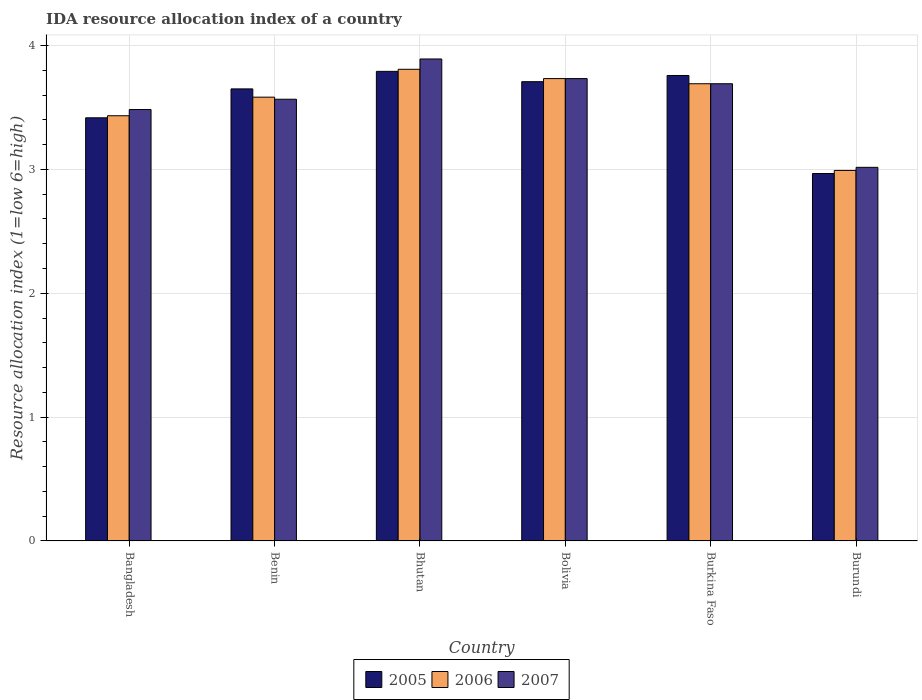How many groups of bars are there?
Offer a very short reply. 6. Are the number of bars on each tick of the X-axis equal?
Your response must be concise. Yes. What is the IDA resource allocation index in 2007 in Burkina Faso?
Your response must be concise. 3.69. Across all countries, what is the maximum IDA resource allocation index in 2005?
Make the answer very short. 3.79. Across all countries, what is the minimum IDA resource allocation index in 2006?
Offer a terse response. 2.99. In which country was the IDA resource allocation index in 2006 maximum?
Your response must be concise. Bhutan. In which country was the IDA resource allocation index in 2005 minimum?
Provide a succinct answer. Burundi. What is the total IDA resource allocation index in 2006 in the graph?
Provide a succinct answer. 21.24. What is the difference between the IDA resource allocation index in 2005 in Bangladesh and that in Bhutan?
Make the answer very short. -0.38. What is the difference between the IDA resource allocation index in 2005 in Bhutan and the IDA resource allocation index in 2006 in Burkina Faso?
Provide a short and direct response. 0.1. What is the average IDA resource allocation index in 2006 per country?
Offer a very short reply. 3.54. What is the difference between the IDA resource allocation index of/in 2005 and IDA resource allocation index of/in 2006 in Bolivia?
Your response must be concise. -0.02. In how many countries, is the IDA resource allocation index in 2005 greater than 2.2?
Give a very brief answer. 6. What is the ratio of the IDA resource allocation index in 2006 in Bolivia to that in Burundi?
Make the answer very short. 1.25. Is the difference between the IDA resource allocation index in 2005 in Benin and Bolivia greater than the difference between the IDA resource allocation index in 2006 in Benin and Bolivia?
Your answer should be very brief. Yes. What is the difference between the highest and the second highest IDA resource allocation index in 2006?
Offer a terse response. 0.04. What is the difference between the highest and the lowest IDA resource allocation index in 2005?
Offer a terse response. 0.83. In how many countries, is the IDA resource allocation index in 2005 greater than the average IDA resource allocation index in 2005 taken over all countries?
Your response must be concise. 4. What does the 1st bar from the left in Burundi represents?
Offer a very short reply. 2005. Is it the case that in every country, the sum of the IDA resource allocation index in 2006 and IDA resource allocation index in 2005 is greater than the IDA resource allocation index in 2007?
Make the answer very short. Yes. How many countries are there in the graph?
Give a very brief answer. 6. What is the difference between two consecutive major ticks on the Y-axis?
Your response must be concise. 1. Are the values on the major ticks of Y-axis written in scientific E-notation?
Provide a short and direct response. No. Does the graph contain any zero values?
Offer a very short reply. No. What is the title of the graph?
Keep it short and to the point. IDA resource allocation index of a country. Does "1995" appear as one of the legend labels in the graph?
Give a very brief answer. No. What is the label or title of the Y-axis?
Keep it short and to the point. Resource allocation index (1=low 6=high). What is the Resource allocation index (1=low 6=high) of 2005 in Bangladesh?
Make the answer very short. 3.42. What is the Resource allocation index (1=low 6=high) of 2006 in Bangladesh?
Offer a terse response. 3.43. What is the Resource allocation index (1=low 6=high) of 2007 in Bangladesh?
Your response must be concise. 3.48. What is the Resource allocation index (1=low 6=high) in 2005 in Benin?
Provide a succinct answer. 3.65. What is the Resource allocation index (1=low 6=high) of 2006 in Benin?
Your answer should be compact. 3.58. What is the Resource allocation index (1=low 6=high) in 2007 in Benin?
Offer a terse response. 3.57. What is the Resource allocation index (1=low 6=high) in 2005 in Bhutan?
Your answer should be compact. 3.79. What is the Resource allocation index (1=low 6=high) of 2006 in Bhutan?
Offer a very short reply. 3.81. What is the Resource allocation index (1=low 6=high) of 2007 in Bhutan?
Provide a short and direct response. 3.89. What is the Resource allocation index (1=low 6=high) of 2005 in Bolivia?
Your answer should be very brief. 3.71. What is the Resource allocation index (1=low 6=high) in 2006 in Bolivia?
Ensure brevity in your answer.  3.73. What is the Resource allocation index (1=low 6=high) in 2007 in Bolivia?
Give a very brief answer. 3.73. What is the Resource allocation index (1=low 6=high) in 2005 in Burkina Faso?
Your answer should be compact. 3.76. What is the Resource allocation index (1=low 6=high) of 2006 in Burkina Faso?
Make the answer very short. 3.69. What is the Resource allocation index (1=low 6=high) of 2007 in Burkina Faso?
Offer a very short reply. 3.69. What is the Resource allocation index (1=low 6=high) of 2005 in Burundi?
Your answer should be very brief. 2.97. What is the Resource allocation index (1=low 6=high) in 2006 in Burundi?
Your answer should be very brief. 2.99. What is the Resource allocation index (1=low 6=high) of 2007 in Burundi?
Your answer should be very brief. 3.02. Across all countries, what is the maximum Resource allocation index (1=low 6=high) of 2005?
Keep it short and to the point. 3.79. Across all countries, what is the maximum Resource allocation index (1=low 6=high) of 2006?
Your answer should be compact. 3.81. Across all countries, what is the maximum Resource allocation index (1=low 6=high) in 2007?
Provide a short and direct response. 3.89. Across all countries, what is the minimum Resource allocation index (1=low 6=high) of 2005?
Keep it short and to the point. 2.97. Across all countries, what is the minimum Resource allocation index (1=low 6=high) of 2006?
Offer a very short reply. 2.99. Across all countries, what is the minimum Resource allocation index (1=low 6=high) of 2007?
Keep it short and to the point. 3.02. What is the total Resource allocation index (1=low 6=high) of 2005 in the graph?
Provide a short and direct response. 21.29. What is the total Resource allocation index (1=low 6=high) in 2006 in the graph?
Make the answer very short. 21.24. What is the total Resource allocation index (1=low 6=high) in 2007 in the graph?
Offer a terse response. 21.38. What is the difference between the Resource allocation index (1=low 6=high) of 2005 in Bangladesh and that in Benin?
Offer a terse response. -0.23. What is the difference between the Resource allocation index (1=low 6=high) in 2006 in Bangladesh and that in Benin?
Ensure brevity in your answer.  -0.15. What is the difference between the Resource allocation index (1=low 6=high) of 2007 in Bangladesh and that in Benin?
Provide a succinct answer. -0.08. What is the difference between the Resource allocation index (1=low 6=high) in 2005 in Bangladesh and that in Bhutan?
Your answer should be compact. -0.38. What is the difference between the Resource allocation index (1=low 6=high) of 2006 in Bangladesh and that in Bhutan?
Keep it short and to the point. -0.38. What is the difference between the Resource allocation index (1=low 6=high) of 2007 in Bangladesh and that in Bhutan?
Offer a very short reply. -0.41. What is the difference between the Resource allocation index (1=low 6=high) of 2005 in Bangladesh and that in Bolivia?
Your response must be concise. -0.29. What is the difference between the Resource allocation index (1=low 6=high) in 2007 in Bangladesh and that in Bolivia?
Keep it short and to the point. -0.25. What is the difference between the Resource allocation index (1=low 6=high) of 2005 in Bangladesh and that in Burkina Faso?
Offer a terse response. -0.34. What is the difference between the Resource allocation index (1=low 6=high) of 2006 in Bangladesh and that in Burkina Faso?
Your answer should be compact. -0.26. What is the difference between the Resource allocation index (1=low 6=high) of 2007 in Bangladesh and that in Burkina Faso?
Your response must be concise. -0.21. What is the difference between the Resource allocation index (1=low 6=high) in 2005 in Bangladesh and that in Burundi?
Provide a succinct answer. 0.45. What is the difference between the Resource allocation index (1=low 6=high) in 2006 in Bangladesh and that in Burundi?
Your answer should be compact. 0.44. What is the difference between the Resource allocation index (1=low 6=high) in 2007 in Bangladesh and that in Burundi?
Keep it short and to the point. 0.47. What is the difference between the Resource allocation index (1=low 6=high) of 2005 in Benin and that in Bhutan?
Offer a very short reply. -0.14. What is the difference between the Resource allocation index (1=low 6=high) in 2006 in Benin and that in Bhutan?
Provide a short and direct response. -0.23. What is the difference between the Resource allocation index (1=low 6=high) of 2007 in Benin and that in Bhutan?
Offer a very short reply. -0.33. What is the difference between the Resource allocation index (1=low 6=high) of 2005 in Benin and that in Bolivia?
Give a very brief answer. -0.06. What is the difference between the Resource allocation index (1=low 6=high) of 2006 in Benin and that in Bolivia?
Make the answer very short. -0.15. What is the difference between the Resource allocation index (1=low 6=high) of 2005 in Benin and that in Burkina Faso?
Provide a short and direct response. -0.11. What is the difference between the Resource allocation index (1=low 6=high) in 2006 in Benin and that in Burkina Faso?
Make the answer very short. -0.11. What is the difference between the Resource allocation index (1=low 6=high) in 2007 in Benin and that in Burkina Faso?
Keep it short and to the point. -0.12. What is the difference between the Resource allocation index (1=low 6=high) in 2005 in Benin and that in Burundi?
Make the answer very short. 0.68. What is the difference between the Resource allocation index (1=low 6=high) of 2006 in Benin and that in Burundi?
Provide a succinct answer. 0.59. What is the difference between the Resource allocation index (1=low 6=high) in 2007 in Benin and that in Burundi?
Your answer should be very brief. 0.55. What is the difference between the Resource allocation index (1=low 6=high) in 2005 in Bhutan and that in Bolivia?
Make the answer very short. 0.08. What is the difference between the Resource allocation index (1=low 6=high) in 2006 in Bhutan and that in Bolivia?
Your response must be concise. 0.07. What is the difference between the Resource allocation index (1=low 6=high) of 2007 in Bhutan and that in Bolivia?
Make the answer very short. 0.16. What is the difference between the Resource allocation index (1=low 6=high) in 2005 in Bhutan and that in Burkina Faso?
Offer a very short reply. 0.03. What is the difference between the Resource allocation index (1=low 6=high) of 2006 in Bhutan and that in Burkina Faso?
Keep it short and to the point. 0.12. What is the difference between the Resource allocation index (1=low 6=high) in 2007 in Bhutan and that in Burkina Faso?
Your response must be concise. 0.2. What is the difference between the Resource allocation index (1=low 6=high) of 2005 in Bhutan and that in Burundi?
Your answer should be compact. 0.82. What is the difference between the Resource allocation index (1=low 6=high) in 2006 in Bhutan and that in Burundi?
Offer a terse response. 0.82. What is the difference between the Resource allocation index (1=low 6=high) in 2006 in Bolivia and that in Burkina Faso?
Offer a very short reply. 0.04. What is the difference between the Resource allocation index (1=low 6=high) of 2007 in Bolivia and that in Burkina Faso?
Give a very brief answer. 0.04. What is the difference between the Resource allocation index (1=low 6=high) of 2005 in Bolivia and that in Burundi?
Give a very brief answer. 0.74. What is the difference between the Resource allocation index (1=low 6=high) in 2006 in Bolivia and that in Burundi?
Your answer should be very brief. 0.74. What is the difference between the Resource allocation index (1=low 6=high) of 2007 in Bolivia and that in Burundi?
Give a very brief answer. 0.72. What is the difference between the Resource allocation index (1=low 6=high) in 2005 in Burkina Faso and that in Burundi?
Your answer should be very brief. 0.79. What is the difference between the Resource allocation index (1=low 6=high) in 2006 in Burkina Faso and that in Burundi?
Provide a succinct answer. 0.7. What is the difference between the Resource allocation index (1=low 6=high) in 2007 in Burkina Faso and that in Burundi?
Make the answer very short. 0.68. What is the difference between the Resource allocation index (1=low 6=high) in 2005 in Bangladesh and the Resource allocation index (1=low 6=high) in 2007 in Benin?
Ensure brevity in your answer.  -0.15. What is the difference between the Resource allocation index (1=low 6=high) in 2006 in Bangladesh and the Resource allocation index (1=low 6=high) in 2007 in Benin?
Keep it short and to the point. -0.13. What is the difference between the Resource allocation index (1=low 6=high) in 2005 in Bangladesh and the Resource allocation index (1=low 6=high) in 2006 in Bhutan?
Provide a succinct answer. -0.39. What is the difference between the Resource allocation index (1=low 6=high) in 2005 in Bangladesh and the Resource allocation index (1=low 6=high) in 2007 in Bhutan?
Your answer should be very brief. -0.47. What is the difference between the Resource allocation index (1=low 6=high) of 2006 in Bangladesh and the Resource allocation index (1=low 6=high) of 2007 in Bhutan?
Keep it short and to the point. -0.46. What is the difference between the Resource allocation index (1=low 6=high) in 2005 in Bangladesh and the Resource allocation index (1=low 6=high) in 2006 in Bolivia?
Ensure brevity in your answer.  -0.32. What is the difference between the Resource allocation index (1=low 6=high) in 2005 in Bangladesh and the Resource allocation index (1=low 6=high) in 2007 in Bolivia?
Give a very brief answer. -0.32. What is the difference between the Resource allocation index (1=low 6=high) of 2006 in Bangladesh and the Resource allocation index (1=low 6=high) of 2007 in Bolivia?
Ensure brevity in your answer.  -0.3. What is the difference between the Resource allocation index (1=low 6=high) of 2005 in Bangladesh and the Resource allocation index (1=low 6=high) of 2006 in Burkina Faso?
Make the answer very short. -0.28. What is the difference between the Resource allocation index (1=low 6=high) of 2005 in Bangladesh and the Resource allocation index (1=low 6=high) of 2007 in Burkina Faso?
Your answer should be very brief. -0.28. What is the difference between the Resource allocation index (1=low 6=high) in 2006 in Bangladesh and the Resource allocation index (1=low 6=high) in 2007 in Burkina Faso?
Your answer should be compact. -0.26. What is the difference between the Resource allocation index (1=low 6=high) in 2005 in Bangladesh and the Resource allocation index (1=low 6=high) in 2006 in Burundi?
Your answer should be compact. 0.42. What is the difference between the Resource allocation index (1=low 6=high) of 2006 in Bangladesh and the Resource allocation index (1=low 6=high) of 2007 in Burundi?
Your response must be concise. 0.42. What is the difference between the Resource allocation index (1=low 6=high) of 2005 in Benin and the Resource allocation index (1=low 6=high) of 2006 in Bhutan?
Provide a succinct answer. -0.16. What is the difference between the Resource allocation index (1=low 6=high) of 2005 in Benin and the Resource allocation index (1=low 6=high) of 2007 in Bhutan?
Your answer should be very brief. -0.24. What is the difference between the Resource allocation index (1=low 6=high) of 2006 in Benin and the Resource allocation index (1=low 6=high) of 2007 in Bhutan?
Your response must be concise. -0.31. What is the difference between the Resource allocation index (1=low 6=high) in 2005 in Benin and the Resource allocation index (1=low 6=high) in 2006 in Bolivia?
Provide a short and direct response. -0.08. What is the difference between the Resource allocation index (1=low 6=high) of 2005 in Benin and the Resource allocation index (1=low 6=high) of 2007 in Bolivia?
Make the answer very short. -0.08. What is the difference between the Resource allocation index (1=low 6=high) of 2006 in Benin and the Resource allocation index (1=low 6=high) of 2007 in Bolivia?
Make the answer very short. -0.15. What is the difference between the Resource allocation index (1=low 6=high) of 2005 in Benin and the Resource allocation index (1=low 6=high) of 2006 in Burkina Faso?
Provide a succinct answer. -0.04. What is the difference between the Resource allocation index (1=low 6=high) in 2005 in Benin and the Resource allocation index (1=low 6=high) in 2007 in Burkina Faso?
Give a very brief answer. -0.04. What is the difference between the Resource allocation index (1=low 6=high) of 2006 in Benin and the Resource allocation index (1=low 6=high) of 2007 in Burkina Faso?
Offer a terse response. -0.11. What is the difference between the Resource allocation index (1=low 6=high) in 2005 in Benin and the Resource allocation index (1=low 6=high) in 2006 in Burundi?
Keep it short and to the point. 0.66. What is the difference between the Resource allocation index (1=low 6=high) in 2005 in Benin and the Resource allocation index (1=low 6=high) in 2007 in Burundi?
Provide a short and direct response. 0.63. What is the difference between the Resource allocation index (1=low 6=high) in 2006 in Benin and the Resource allocation index (1=low 6=high) in 2007 in Burundi?
Offer a very short reply. 0.57. What is the difference between the Resource allocation index (1=low 6=high) in 2005 in Bhutan and the Resource allocation index (1=low 6=high) in 2006 in Bolivia?
Offer a very short reply. 0.06. What is the difference between the Resource allocation index (1=low 6=high) in 2005 in Bhutan and the Resource allocation index (1=low 6=high) in 2007 in Bolivia?
Your response must be concise. 0.06. What is the difference between the Resource allocation index (1=low 6=high) in 2006 in Bhutan and the Resource allocation index (1=low 6=high) in 2007 in Bolivia?
Your response must be concise. 0.07. What is the difference between the Resource allocation index (1=low 6=high) of 2005 in Bhutan and the Resource allocation index (1=low 6=high) of 2006 in Burkina Faso?
Your answer should be compact. 0.1. What is the difference between the Resource allocation index (1=low 6=high) of 2006 in Bhutan and the Resource allocation index (1=low 6=high) of 2007 in Burkina Faso?
Make the answer very short. 0.12. What is the difference between the Resource allocation index (1=low 6=high) in 2005 in Bhutan and the Resource allocation index (1=low 6=high) in 2007 in Burundi?
Keep it short and to the point. 0.78. What is the difference between the Resource allocation index (1=low 6=high) of 2006 in Bhutan and the Resource allocation index (1=low 6=high) of 2007 in Burundi?
Provide a short and direct response. 0.79. What is the difference between the Resource allocation index (1=low 6=high) of 2005 in Bolivia and the Resource allocation index (1=low 6=high) of 2006 in Burkina Faso?
Ensure brevity in your answer.  0.02. What is the difference between the Resource allocation index (1=low 6=high) in 2005 in Bolivia and the Resource allocation index (1=low 6=high) in 2007 in Burkina Faso?
Provide a succinct answer. 0.02. What is the difference between the Resource allocation index (1=low 6=high) of 2006 in Bolivia and the Resource allocation index (1=low 6=high) of 2007 in Burkina Faso?
Keep it short and to the point. 0.04. What is the difference between the Resource allocation index (1=low 6=high) in 2005 in Bolivia and the Resource allocation index (1=low 6=high) in 2006 in Burundi?
Make the answer very short. 0.72. What is the difference between the Resource allocation index (1=low 6=high) of 2005 in Bolivia and the Resource allocation index (1=low 6=high) of 2007 in Burundi?
Your answer should be compact. 0.69. What is the difference between the Resource allocation index (1=low 6=high) of 2006 in Bolivia and the Resource allocation index (1=low 6=high) of 2007 in Burundi?
Your answer should be compact. 0.72. What is the difference between the Resource allocation index (1=low 6=high) of 2005 in Burkina Faso and the Resource allocation index (1=low 6=high) of 2006 in Burundi?
Offer a terse response. 0.77. What is the difference between the Resource allocation index (1=low 6=high) of 2005 in Burkina Faso and the Resource allocation index (1=low 6=high) of 2007 in Burundi?
Your response must be concise. 0.74. What is the difference between the Resource allocation index (1=low 6=high) in 2006 in Burkina Faso and the Resource allocation index (1=low 6=high) in 2007 in Burundi?
Provide a short and direct response. 0.68. What is the average Resource allocation index (1=low 6=high) in 2005 per country?
Provide a succinct answer. 3.55. What is the average Resource allocation index (1=low 6=high) of 2006 per country?
Provide a short and direct response. 3.54. What is the average Resource allocation index (1=low 6=high) of 2007 per country?
Your answer should be very brief. 3.56. What is the difference between the Resource allocation index (1=low 6=high) of 2005 and Resource allocation index (1=low 6=high) of 2006 in Bangladesh?
Your answer should be very brief. -0.02. What is the difference between the Resource allocation index (1=low 6=high) in 2005 and Resource allocation index (1=low 6=high) in 2007 in Bangladesh?
Offer a very short reply. -0.07. What is the difference between the Resource allocation index (1=low 6=high) in 2006 and Resource allocation index (1=low 6=high) in 2007 in Bangladesh?
Your response must be concise. -0.05. What is the difference between the Resource allocation index (1=low 6=high) of 2005 and Resource allocation index (1=low 6=high) of 2006 in Benin?
Your response must be concise. 0.07. What is the difference between the Resource allocation index (1=low 6=high) in 2005 and Resource allocation index (1=low 6=high) in 2007 in Benin?
Provide a succinct answer. 0.08. What is the difference between the Resource allocation index (1=low 6=high) in 2006 and Resource allocation index (1=low 6=high) in 2007 in Benin?
Keep it short and to the point. 0.02. What is the difference between the Resource allocation index (1=low 6=high) of 2005 and Resource allocation index (1=low 6=high) of 2006 in Bhutan?
Ensure brevity in your answer.  -0.02. What is the difference between the Resource allocation index (1=low 6=high) of 2005 and Resource allocation index (1=low 6=high) of 2007 in Bhutan?
Make the answer very short. -0.1. What is the difference between the Resource allocation index (1=low 6=high) of 2006 and Resource allocation index (1=low 6=high) of 2007 in Bhutan?
Ensure brevity in your answer.  -0.08. What is the difference between the Resource allocation index (1=low 6=high) in 2005 and Resource allocation index (1=low 6=high) in 2006 in Bolivia?
Offer a very short reply. -0.03. What is the difference between the Resource allocation index (1=low 6=high) of 2005 and Resource allocation index (1=low 6=high) of 2007 in Bolivia?
Give a very brief answer. -0.03. What is the difference between the Resource allocation index (1=low 6=high) of 2006 and Resource allocation index (1=low 6=high) of 2007 in Bolivia?
Your answer should be very brief. 0. What is the difference between the Resource allocation index (1=low 6=high) of 2005 and Resource allocation index (1=low 6=high) of 2006 in Burkina Faso?
Your answer should be compact. 0.07. What is the difference between the Resource allocation index (1=low 6=high) in 2005 and Resource allocation index (1=low 6=high) in 2007 in Burkina Faso?
Give a very brief answer. 0.07. What is the difference between the Resource allocation index (1=low 6=high) in 2005 and Resource allocation index (1=low 6=high) in 2006 in Burundi?
Your answer should be very brief. -0.03. What is the difference between the Resource allocation index (1=low 6=high) in 2005 and Resource allocation index (1=low 6=high) in 2007 in Burundi?
Ensure brevity in your answer.  -0.05. What is the difference between the Resource allocation index (1=low 6=high) in 2006 and Resource allocation index (1=low 6=high) in 2007 in Burundi?
Provide a short and direct response. -0.03. What is the ratio of the Resource allocation index (1=low 6=high) in 2005 in Bangladesh to that in Benin?
Your response must be concise. 0.94. What is the ratio of the Resource allocation index (1=low 6=high) of 2006 in Bangladesh to that in Benin?
Your answer should be compact. 0.96. What is the ratio of the Resource allocation index (1=low 6=high) of 2007 in Bangladesh to that in Benin?
Offer a very short reply. 0.98. What is the ratio of the Resource allocation index (1=low 6=high) of 2005 in Bangladesh to that in Bhutan?
Ensure brevity in your answer.  0.9. What is the ratio of the Resource allocation index (1=low 6=high) in 2006 in Bangladesh to that in Bhutan?
Provide a short and direct response. 0.9. What is the ratio of the Resource allocation index (1=low 6=high) of 2007 in Bangladesh to that in Bhutan?
Give a very brief answer. 0.9. What is the ratio of the Resource allocation index (1=low 6=high) in 2005 in Bangladesh to that in Bolivia?
Provide a short and direct response. 0.92. What is the ratio of the Resource allocation index (1=low 6=high) in 2006 in Bangladesh to that in Bolivia?
Give a very brief answer. 0.92. What is the ratio of the Resource allocation index (1=low 6=high) of 2007 in Bangladesh to that in Bolivia?
Your response must be concise. 0.93. What is the ratio of the Resource allocation index (1=low 6=high) of 2005 in Bangladesh to that in Burkina Faso?
Ensure brevity in your answer.  0.91. What is the ratio of the Resource allocation index (1=low 6=high) in 2007 in Bangladesh to that in Burkina Faso?
Your answer should be very brief. 0.94. What is the ratio of the Resource allocation index (1=low 6=high) in 2005 in Bangladesh to that in Burundi?
Your response must be concise. 1.15. What is the ratio of the Resource allocation index (1=low 6=high) of 2006 in Bangladesh to that in Burundi?
Offer a very short reply. 1.15. What is the ratio of the Resource allocation index (1=low 6=high) of 2007 in Bangladesh to that in Burundi?
Offer a very short reply. 1.15. What is the ratio of the Resource allocation index (1=low 6=high) of 2005 in Benin to that in Bhutan?
Your response must be concise. 0.96. What is the ratio of the Resource allocation index (1=low 6=high) in 2006 in Benin to that in Bhutan?
Your answer should be compact. 0.94. What is the ratio of the Resource allocation index (1=low 6=high) of 2007 in Benin to that in Bhutan?
Offer a very short reply. 0.92. What is the ratio of the Resource allocation index (1=low 6=high) in 2005 in Benin to that in Bolivia?
Ensure brevity in your answer.  0.98. What is the ratio of the Resource allocation index (1=low 6=high) in 2006 in Benin to that in Bolivia?
Offer a very short reply. 0.96. What is the ratio of the Resource allocation index (1=low 6=high) of 2007 in Benin to that in Bolivia?
Offer a terse response. 0.96. What is the ratio of the Resource allocation index (1=low 6=high) of 2005 in Benin to that in Burkina Faso?
Give a very brief answer. 0.97. What is the ratio of the Resource allocation index (1=low 6=high) of 2006 in Benin to that in Burkina Faso?
Provide a succinct answer. 0.97. What is the ratio of the Resource allocation index (1=low 6=high) in 2007 in Benin to that in Burkina Faso?
Your response must be concise. 0.97. What is the ratio of the Resource allocation index (1=low 6=high) of 2005 in Benin to that in Burundi?
Provide a short and direct response. 1.23. What is the ratio of the Resource allocation index (1=low 6=high) of 2006 in Benin to that in Burundi?
Offer a terse response. 1.2. What is the ratio of the Resource allocation index (1=low 6=high) of 2007 in Benin to that in Burundi?
Provide a succinct answer. 1.18. What is the ratio of the Resource allocation index (1=low 6=high) in 2005 in Bhutan to that in Bolivia?
Provide a succinct answer. 1.02. What is the ratio of the Resource allocation index (1=low 6=high) in 2006 in Bhutan to that in Bolivia?
Keep it short and to the point. 1.02. What is the ratio of the Resource allocation index (1=low 6=high) of 2007 in Bhutan to that in Bolivia?
Ensure brevity in your answer.  1.04. What is the ratio of the Resource allocation index (1=low 6=high) in 2005 in Bhutan to that in Burkina Faso?
Give a very brief answer. 1.01. What is the ratio of the Resource allocation index (1=low 6=high) in 2006 in Bhutan to that in Burkina Faso?
Keep it short and to the point. 1.03. What is the ratio of the Resource allocation index (1=low 6=high) of 2007 in Bhutan to that in Burkina Faso?
Give a very brief answer. 1.05. What is the ratio of the Resource allocation index (1=low 6=high) in 2005 in Bhutan to that in Burundi?
Your answer should be compact. 1.28. What is the ratio of the Resource allocation index (1=low 6=high) in 2006 in Bhutan to that in Burundi?
Keep it short and to the point. 1.27. What is the ratio of the Resource allocation index (1=low 6=high) of 2007 in Bhutan to that in Burundi?
Your answer should be compact. 1.29. What is the ratio of the Resource allocation index (1=low 6=high) of 2005 in Bolivia to that in Burkina Faso?
Your answer should be compact. 0.99. What is the ratio of the Resource allocation index (1=low 6=high) in 2006 in Bolivia to that in Burkina Faso?
Your response must be concise. 1.01. What is the ratio of the Resource allocation index (1=low 6=high) in 2007 in Bolivia to that in Burkina Faso?
Your answer should be compact. 1.01. What is the ratio of the Resource allocation index (1=low 6=high) of 2006 in Bolivia to that in Burundi?
Make the answer very short. 1.25. What is the ratio of the Resource allocation index (1=low 6=high) of 2007 in Bolivia to that in Burundi?
Your response must be concise. 1.24. What is the ratio of the Resource allocation index (1=low 6=high) of 2005 in Burkina Faso to that in Burundi?
Your response must be concise. 1.27. What is the ratio of the Resource allocation index (1=low 6=high) of 2006 in Burkina Faso to that in Burundi?
Provide a short and direct response. 1.23. What is the ratio of the Resource allocation index (1=low 6=high) of 2007 in Burkina Faso to that in Burundi?
Keep it short and to the point. 1.22. What is the difference between the highest and the second highest Resource allocation index (1=low 6=high) in 2005?
Make the answer very short. 0.03. What is the difference between the highest and the second highest Resource allocation index (1=low 6=high) in 2006?
Provide a short and direct response. 0.07. What is the difference between the highest and the second highest Resource allocation index (1=low 6=high) in 2007?
Provide a short and direct response. 0.16. What is the difference between the highest and the lowest Resource allocation index (1=low 6=high) in 2005?
Ensure brevity in your answer.  0.82. What is the difference between the highest and the lowest Resource allocation index (1=low 6=high) of 2006?
Ensure brevity in your answer.  0.82. 